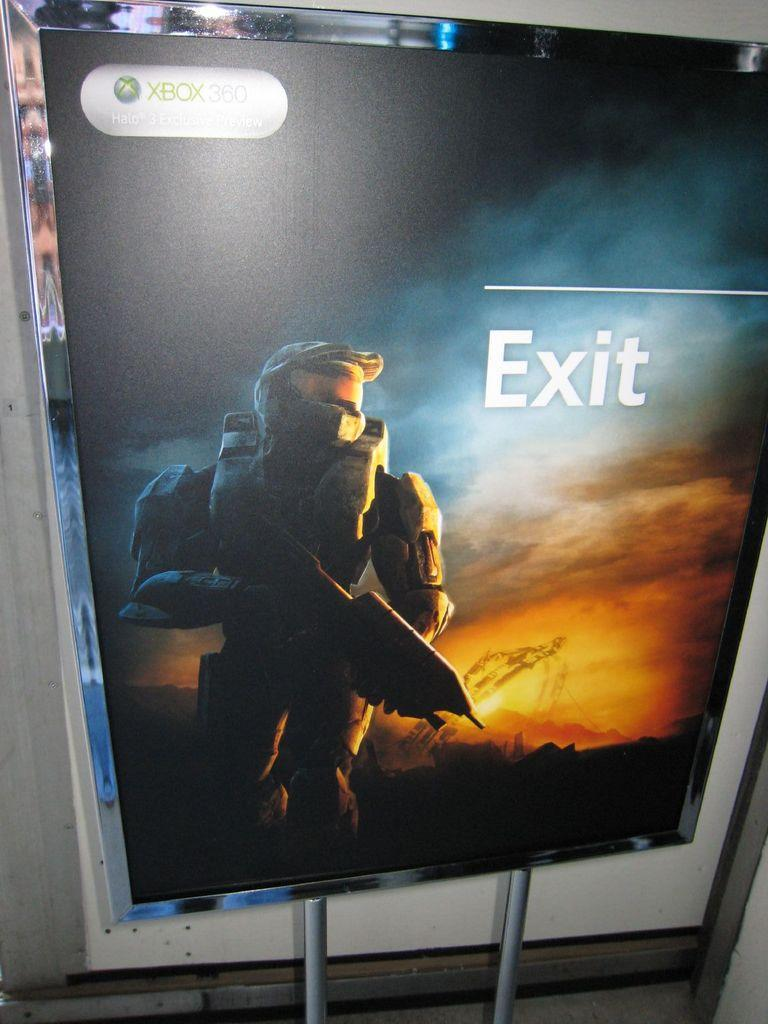<image>
Relay a brief, clear account of the picture shown. A Xbox 360 game advertisement board featuring Halo and signaling the exit of the room. 